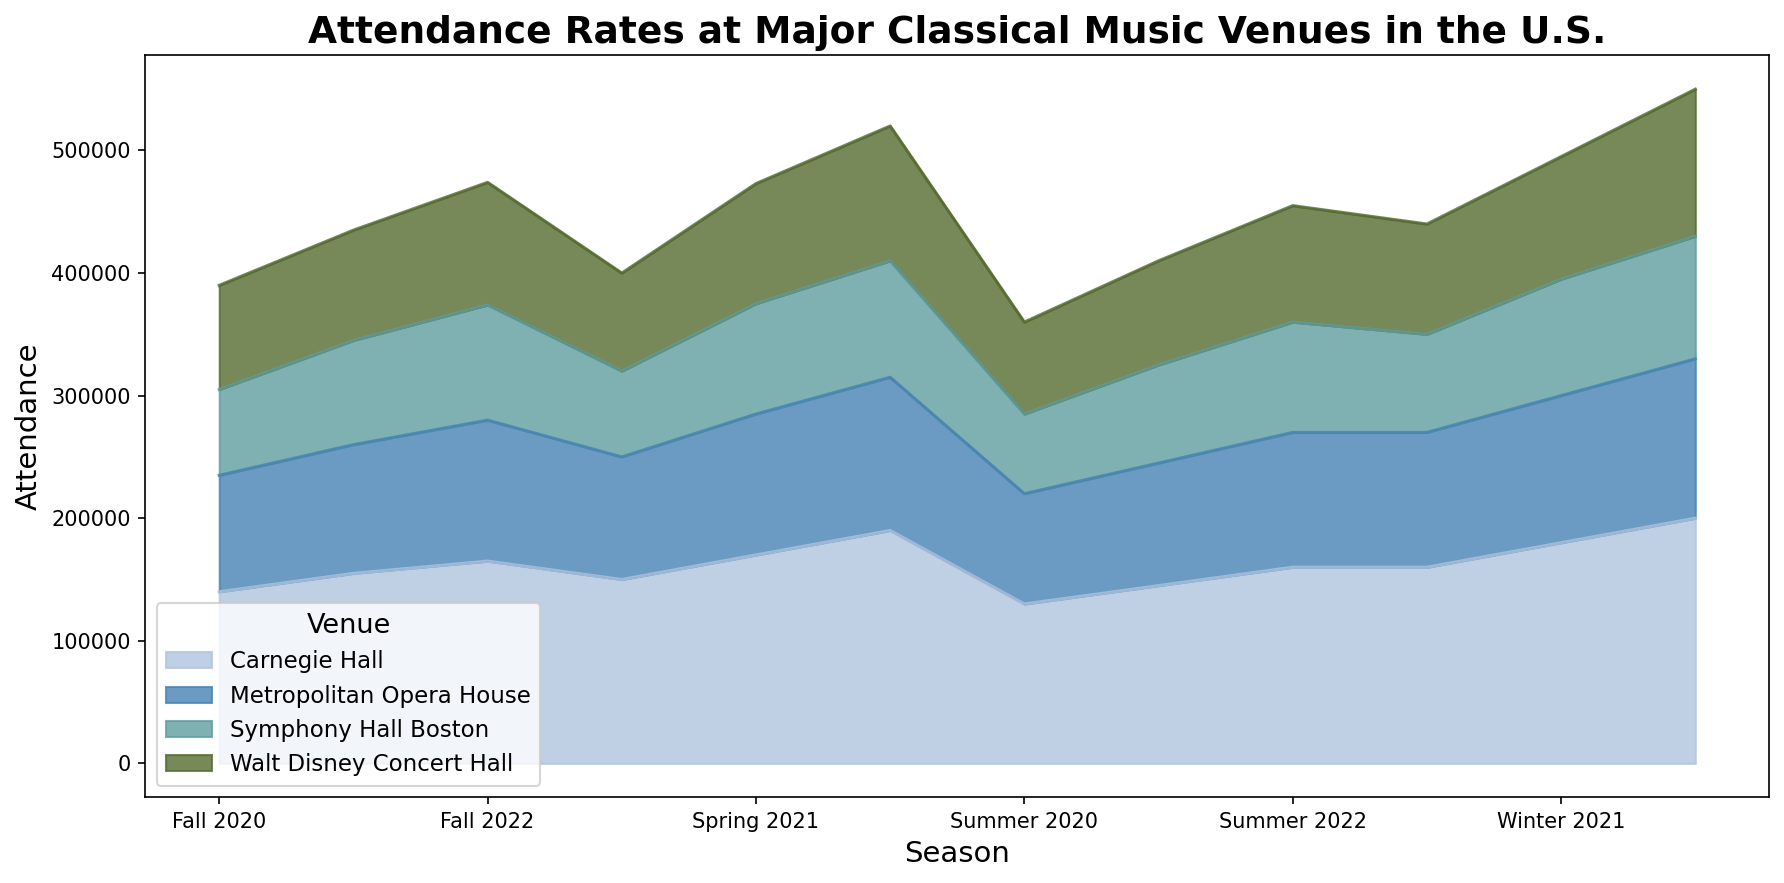How does the attendance at Carnegie Hall in Winter 2020 compare to Spring 2022? Look at the attendance numbers for Carnegie Hall in Winter 2020 and Spring 2022 from the plot. Winter 2020 has 160,000 attendees, whereas Spring 2022 has 190,000 attendees.
Answer: Winter 2020 has 30,000 fewer attendees Which season in 2021 had the highest total attendance across all venues? Sum the attendance for all venues in each season in 2021. For Spring: 170,000 + 115,000 + 98,000 + 90,000 = 473,000. For Summer: 145,000 + 100,000 + 85,000 + 80,000 = 410,000. For Fall: 155,000 + 105,000 + 90,000 + 85,000 = 435,000. For Winter: 180,000 + 120,000 + 100,000 + 95,000 = 495,000. Winter 2021 has the highest total attendance.
Answer: Winter 2021 What was the general trend in attendance at Symphony Hall Boston from 2020 to 2022? Observe the plot area corresponding to Symphony Hall Boston from 2020 to 2022. Attendance gradually increases overall, with minor seasonal fluctuations, peaking in Winter 2022.
Answer: Increasing trend Which venue had the least attendance in Summer 2020? Visualize the area corresponding to each venue for Summer 2020. The plot shows Symphony Hall Boston has the smallest area representing the least attendance.
Answer: Symphony Hall Boston In which season of 2022 did Carnegie Hall see the lowest attendance and what was the number? Examine the attendance numbers for Carnegie Hall across each season in 2022. The lowest attendance is in Summer 2022 with 160,000 attendees.
Answer: Summer 2022, 160,000 Calculate the difference in attendance between Walt Disney Concert Hall and Metropolitan Opera House in Fall 2022. Look at the Fall 2022 attendance for both Walt Disney Concert Hall (100,000) and Metropolitan Opera House (115,000) on the plot. The difference is 115,000 - 100,000 = 15,000.
Answer: 15,000 What pattern can you observe in the attendance at the venues during Winter seasons across different years? Analyze the attendance patterns for Winter seasons (2020, 2021, 2022) for each venue in the plot. There is a consistent increase in attendance each Winter season across all venues.
Answer: Consistent increase Which season had the second-highest attendance at Metropolitan Opera House in the entire dataset? Compare the attendance at Metropolitan Opera House across all seasons. Winter 2022 had the highest with 130,000, and Spring 2022 had the second-highest with 125,000.
Answer: Spring 2022 How does the total attendance in Fall 2020 compare with Fall 2021? Calculate the total attendance for Fall 2020 (140,000 + 95,000 + 85,000 + 70,000 = 390,000) and Fall 2021 (155,000 + 105,000 + 90,000 + 85,000 = 435,000). Fall 2021 has more total attendance.
Answer: Fall 2021 has 45,000 more Which venue showed the highest increase in attendance from Summer 2021 to Winter 2022? Calculate the attendance increase for each venue from Summer 2021 to Winter 2022. For Carnegie Hall: 200,000 - 145,000 = 55,000, Metropolitan Opera House: 130,000 - 100,000 = 30,000, Walt Disney Concert Hall: 120,000 - 85,000 = 35,000, Symphony Hall Boston: 100,000 - 80,000 = 20,000. Carnegie Hall showed the highest increase.
Answer: Carnegie Hall 